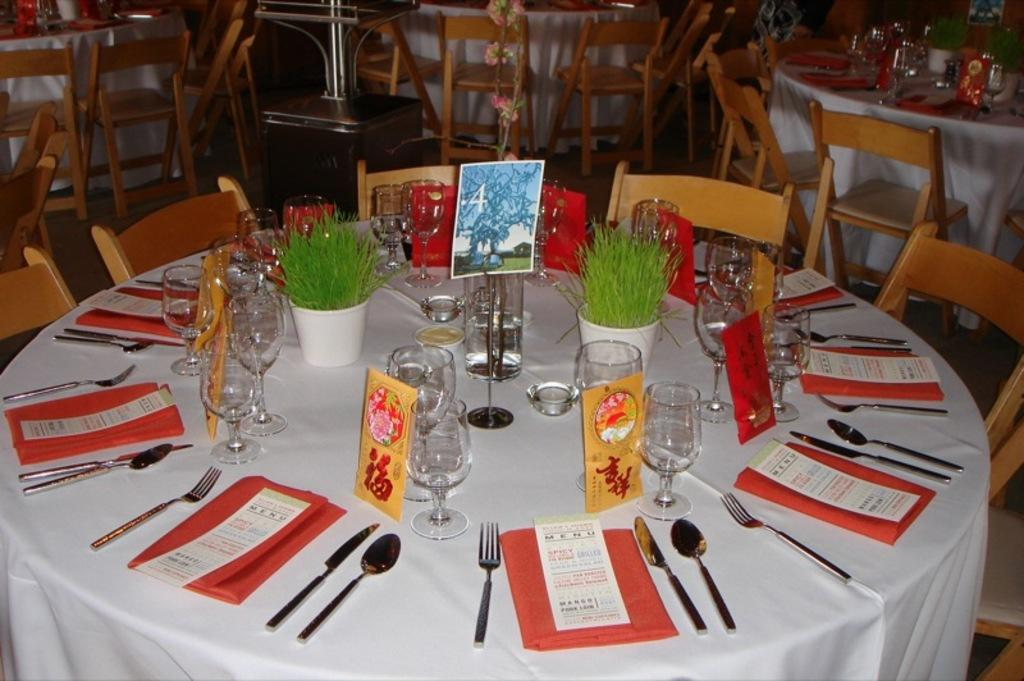What type of furniture is present in the image? There is a table in the image. What accompanies the table in the image? There are chairs around the table. What utensils can be seen on the table? There are forks, spoons, and knives on the table. What is used for drinking in the image? There is a glass on the table. What item is present for wiping or cleaning in the image? There are napkins in the image. How many grapes are on the table in the image? There are no grapes present on the table in the image. What type of animal is sitting at the table in the image? There are no animals present in the image; it features a table with chairs and utensils. 